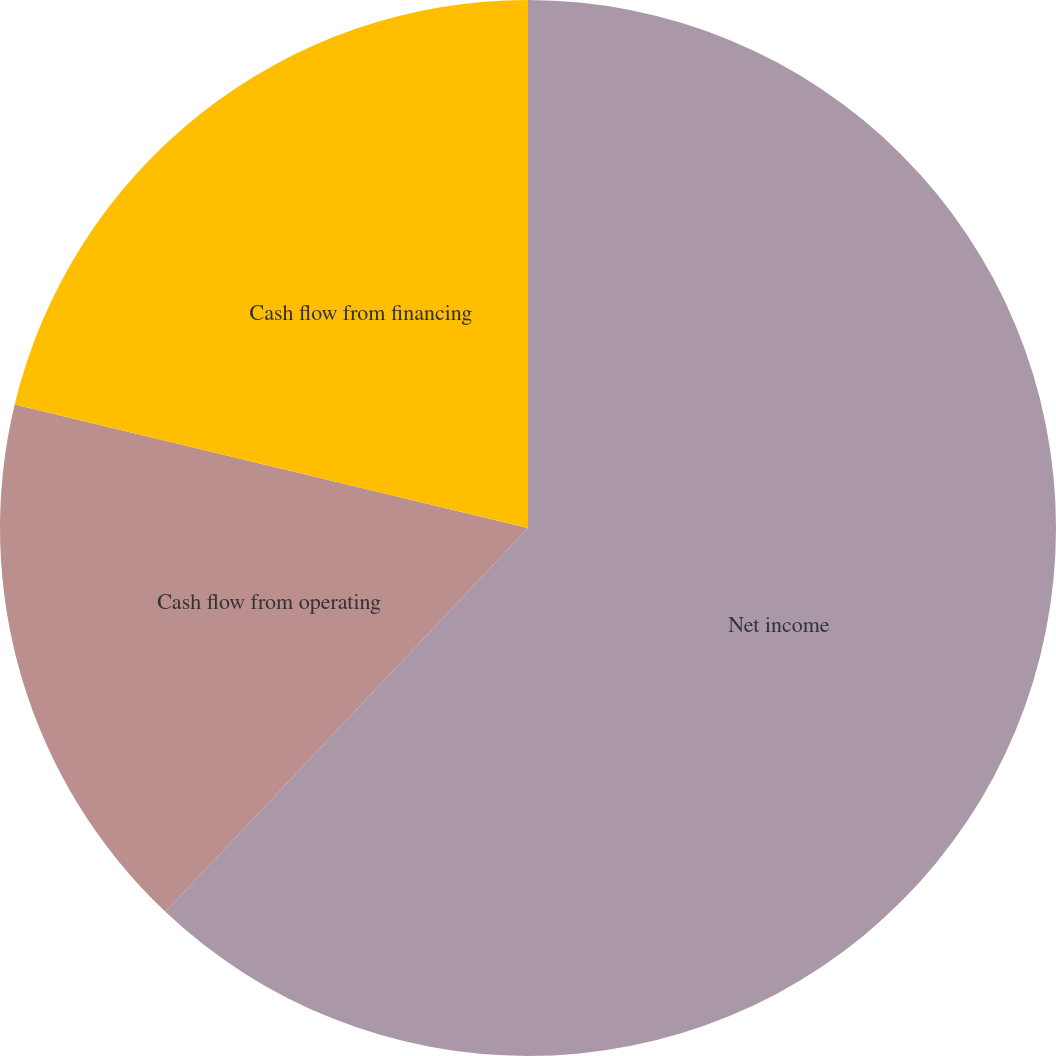Convert chart to OTSL. <chart><loc_0><loc_0><loc_500><loc_500><pie_chart><fcel>Net income<fcel>Cash flow from operating<fcel>Cash flow from financing<nl><fcel>62.05%<fcel>16.71%<fcel>21.24%<nl></chart> 